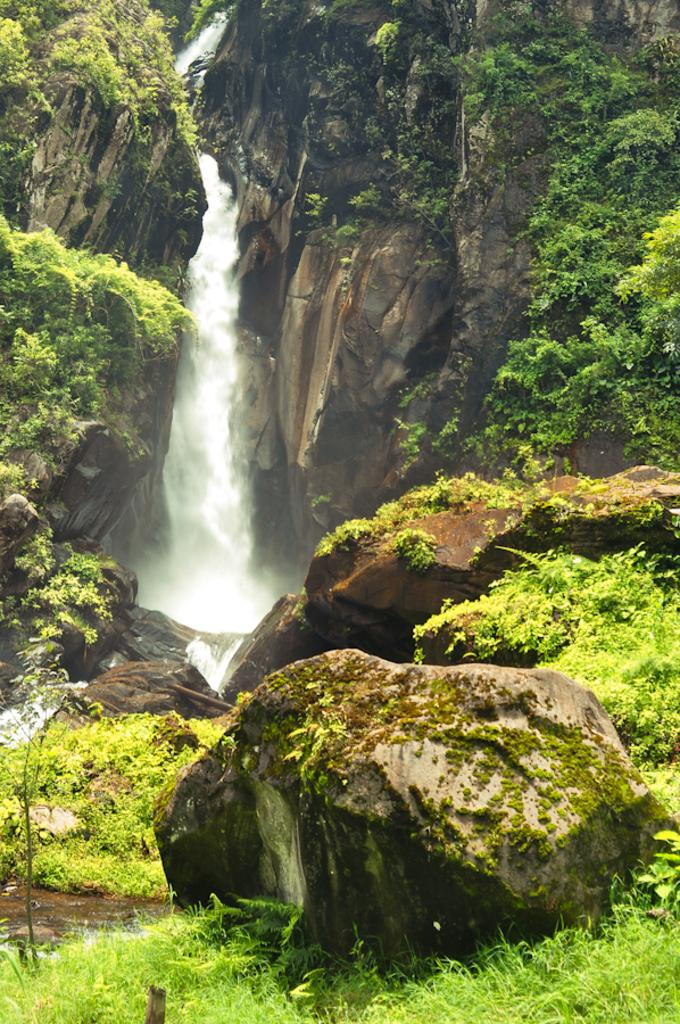What natural feature is the main subject of the image? There is a waterfall in the image. How is the water moving in the image? The water is flowing through hills in the image. What type of geological formation can be seen in the image? There is a rock in the image. What type of vegetation is present in the image? There are trees and grass in the image. How many ghosts are visible in the image? There are no ghosts present in the image; it features a waterfall, hills, a rock, trees, and grass. What type of plastic object can be seen in the image? There is no plastic object present in the image. 